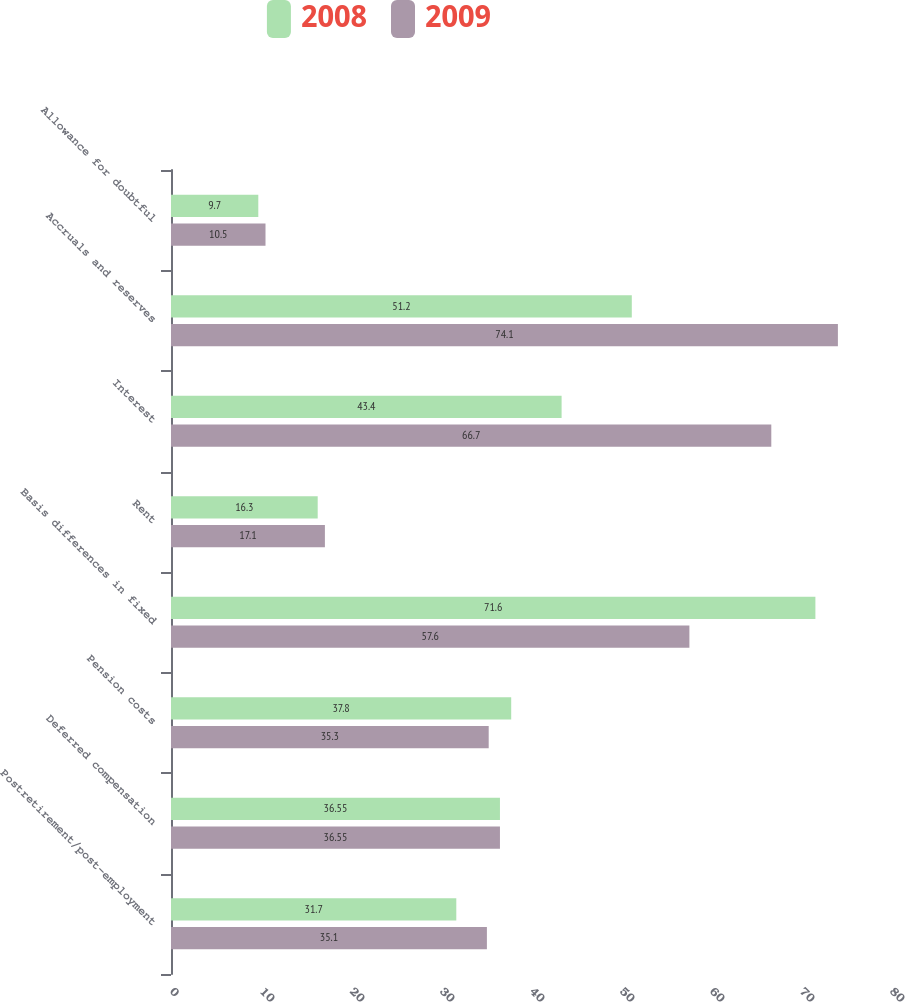<chart> <loc_0><loc_0><loc_500><loc_500><stacked_bar_chart><ecel><fcel>Postretirement/post-employment<fcel>Deferred compensation<fcel>Pension costs<fcel>Basis differences in fixed<fcel>Rent<fcel>Interest<fcel>Accruals and reserves<fcel>Allowance for doubtful<nl><fcel>2008<fcel>31.7<fcel>36.55<fcel>37.8<fcel>71.6<fcel>16.3<fcel>43.4<fcel>51.2<fcel>9.7<nl><fcel>2009<fcel>35.1<fcel>36.55<fcel>35.3<fcel>57.6<fcel>17.1<fcel>66.7<fcel>74.1<fcel>10.5<nl></chart> 